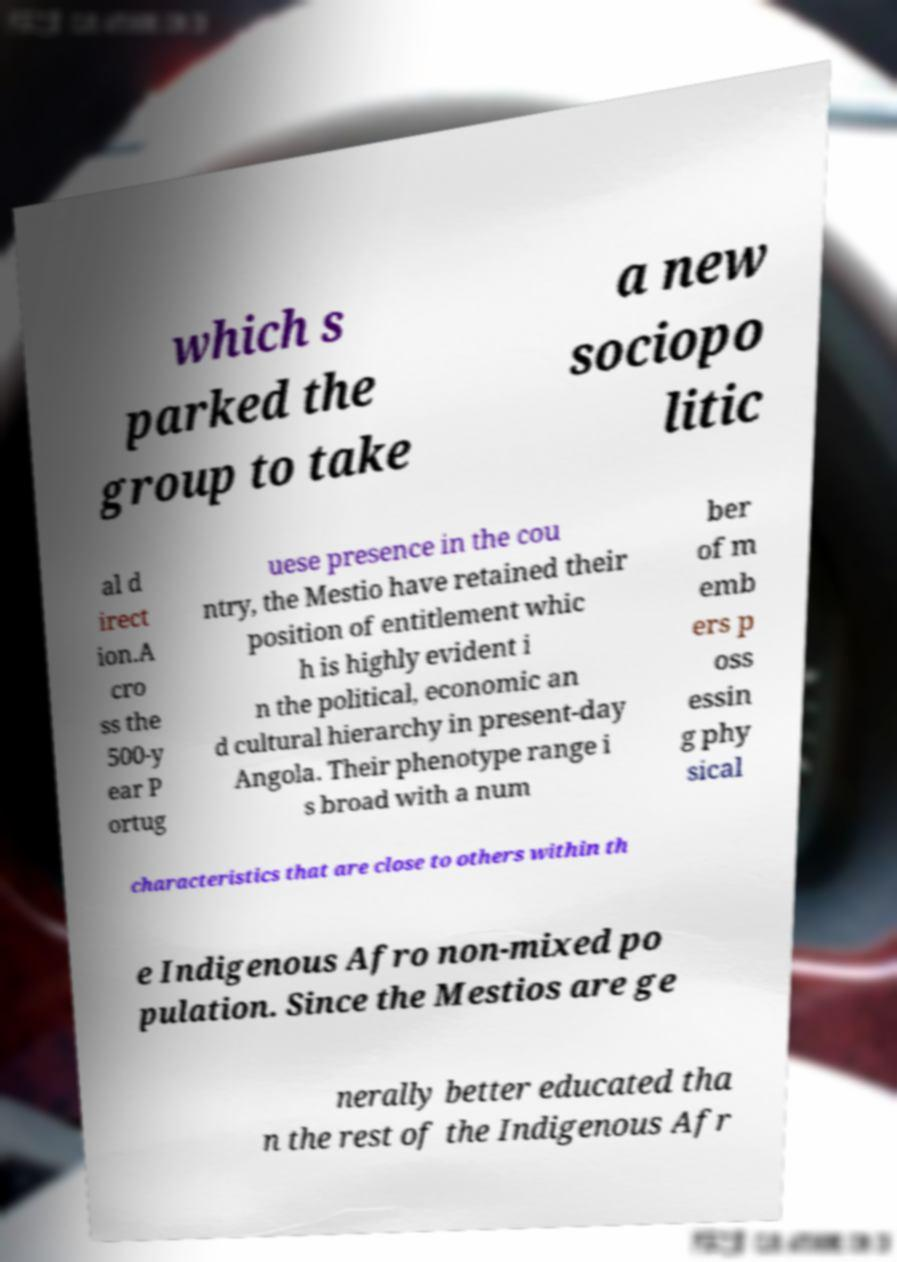Could you extract and type out the text from this image? which s parked the group to take a new sociopo litic al d irect ion.A cro ss the 500-y ear P ortug uese presence in the cou ntry, the Mestio have retained their position of entitlement whic h is highly evident i n the political, economic an d cultural hierarchy in present-day Angola. Their phenotype range i s broad with a num ber of m emb ers p oss essin g phy sical characteristics that are close to others within th e Indigenous Afro non-mixed po pulation. Since the Mestios are ge nerally better educated tha n the rest of the Indigenous Afr 